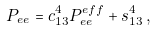Convert formula to latex. <formula><loc_0><loc_0><loc_500><loc_500>P _ { e e } = c _ { 1 3 } ^ { 4 } P _ { e e } ^ { e f f } + s _ { 1 3 } ^ { 4 } \, ,</formula> 